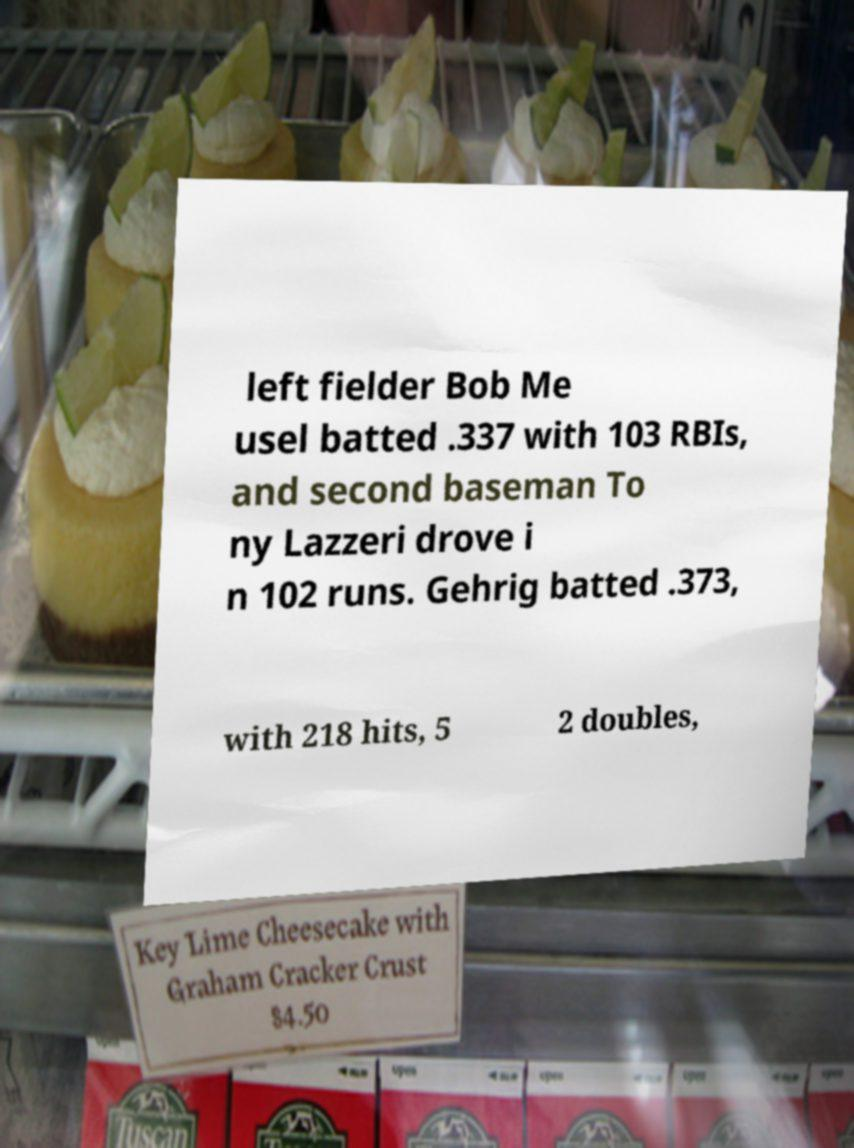Could you extract and type out the text from this image? left fielder Bob Me usel batted .337 with 103 RBIs, and second baseman To ny Lazzeri drove i n 102 runs. Gehrig batted .373, with 218 hits, 5 2 doubles, 